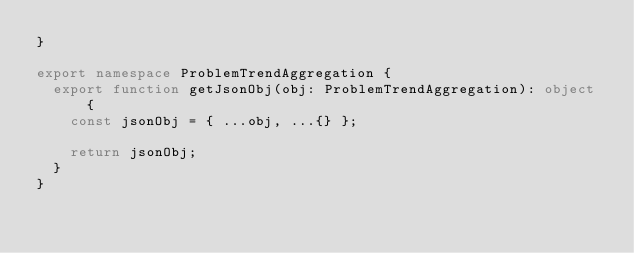<code> <loc_0><loc_0><loc_500><loc_500><_TypeScript_>}

export namespace ProblemTrendAggregation {
  export function getJsonObj(obj: ProblemTrendAggregation): object {
    const jsonObj = { ...obj, ...{} };

    return jsonObj;
  }
}
</code> 